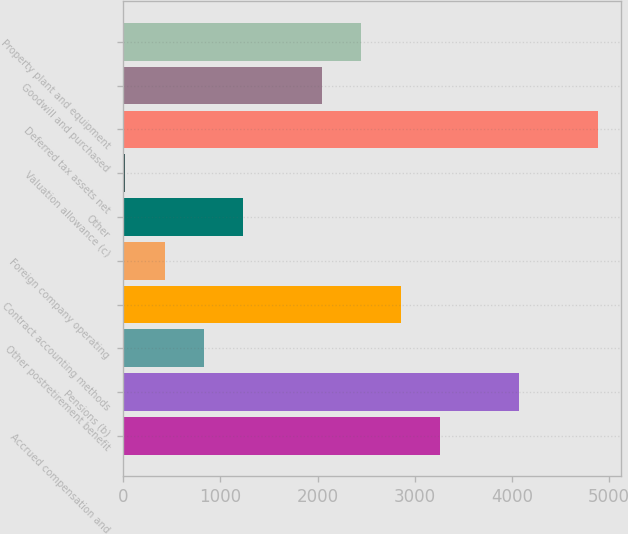<chart> <loc_0><loc_0><loc_500><loc_500><bar_chart><fcel>Accrued compensation and<fcel>Pensions (b)<fcel>Other postretirement benefit<fcel>Contract accounting methods<fcel>Foreign company operating<fcel>Other<fcel>Valuation allowance (c)<fcel>Deferred tax assets net<fcel>Goodwill and purchased<fcel>Property plant and equipment<nl><fcel>3261.6<fcel>4072<fcel>830.4<fcel>2856.4<fcel>425.2<fcel>1235.6<fcel>20<fcel>4882.4<fcel>2046<fcel>2451.2<nl></chart> 